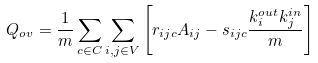Convert formula to latex. <formula><loc_0><loc_0><loc_500><loc_500>Q _ { o v } = \frac { 1 } { m } \sum _ { c \in C } \sum _ { i , j \in V } \left [ r _ { i j c } A _ { i j } - s _ { i j c } \frac { k _ { i } ^ { o u t } k _ { j } ^ { i n } } { m } \right ]</formula> 